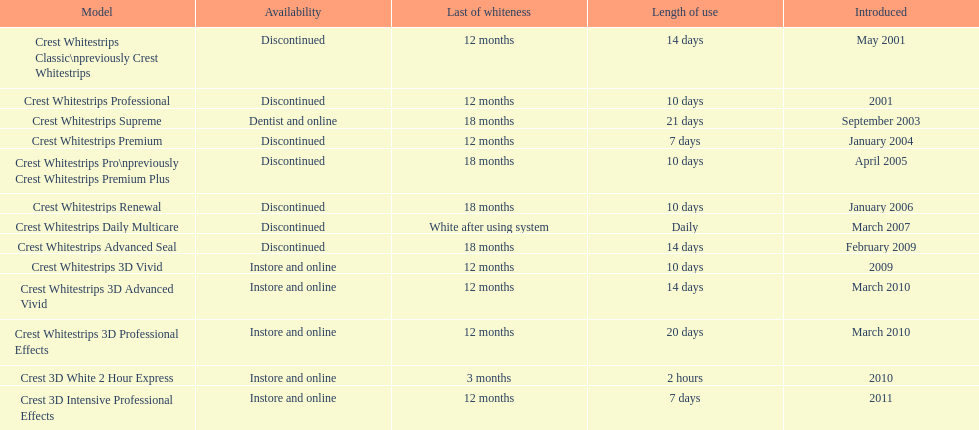Which model has the highest 'length of use' to 'last of whiteness' ratio? Crest Whitestrips Supreme. 